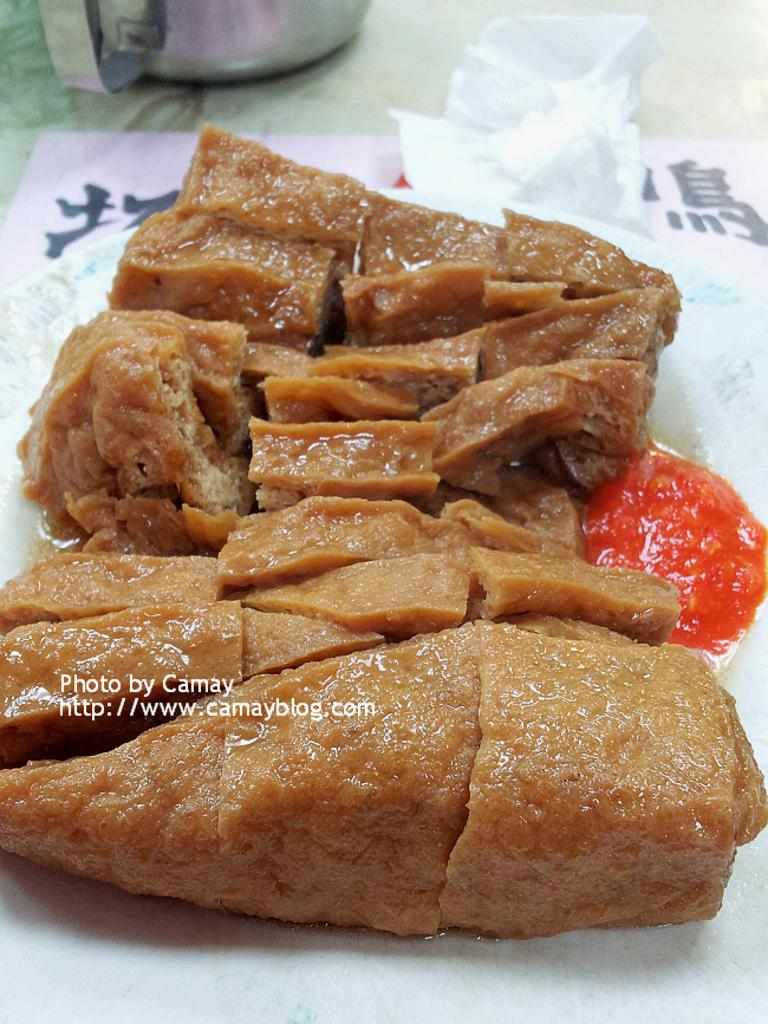What is on the plate in the image? There is food on a plate in the image. What else can be seen on a surface in the image? There is paper on a surface in the image. Can you describe the object that appears to be truncated towards the top of the image? The object appears to be truncated towards the top of the image, but its exact nature cannot be determined from the provided facts. What type of information is visible in the image? There is text visible in the image. What type of fowl can be seen swimming in the sea in the image? There is no fowl or sea present in the image; it features food on a plate, paper on a surface, a truncated object, and text. What type of trade is being conducted in the image? There is no trade or indication of any commercial activity in the image. 